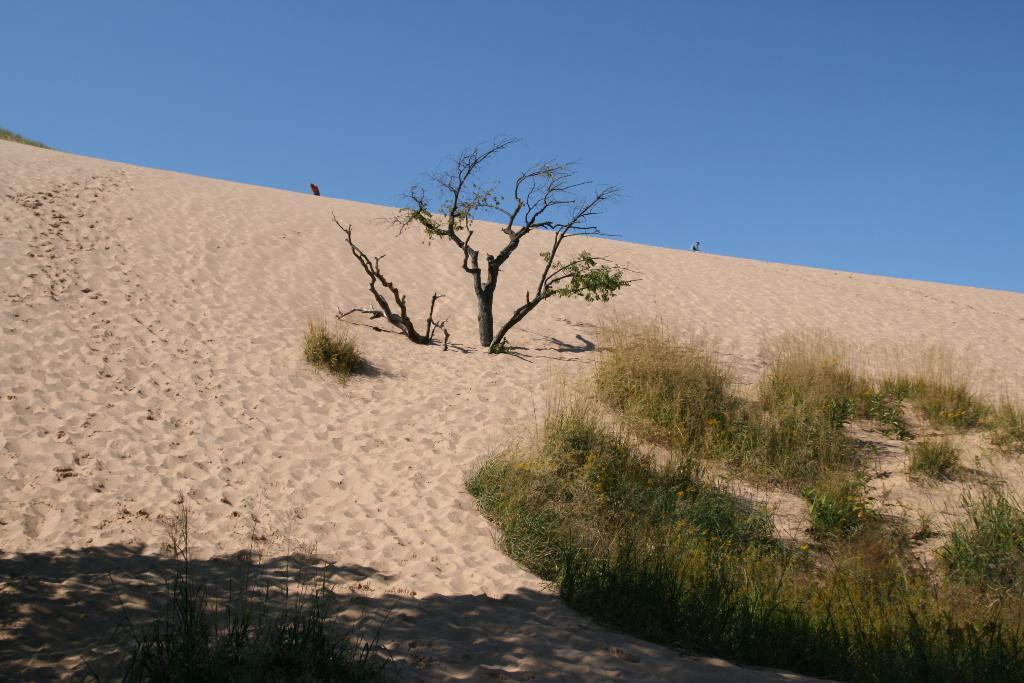What type of geographical feature is present in the image? There is a sand hill in the image. What other natural elements can be seen in the image? There are plants in the bottom right of the image and a tree in the middle of the image. What is visible at the top of the image? The sky is visible at the top of the image. What type of crime is being committed in the image? There is no indication of any crime being committed in the image; it features a sand hill, plants, a tree, and the sky. How many passengers are visible in the image? There are no passengers present in the image. 